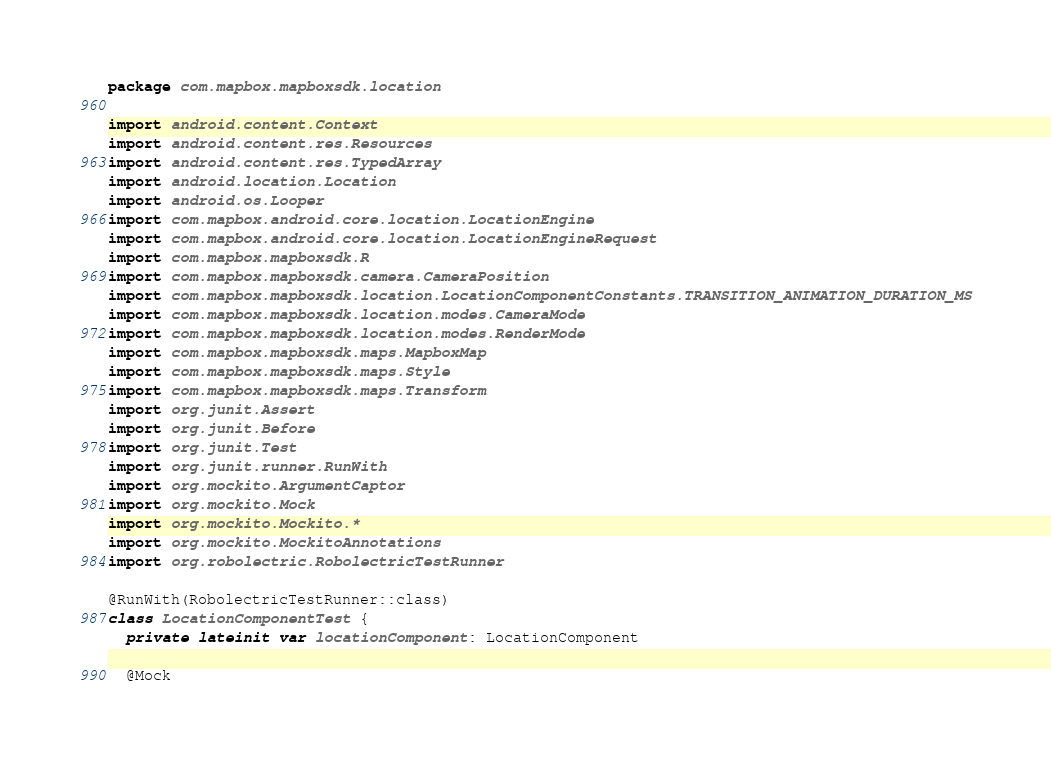<code> <loc_0><loc_0><loc_500><loc_500><_Kotlin_>package com.mapbox.mapboxsdk.location

import android.content.Context
import android.content.res.Resources
import android.content.res.TypedArray
import android.location.Location
import android.os.Looper
import com.mapbox.android.core.location.LocationEngine
import com.mapbox.android.core.location.LocationEngineRequest
import com.mapbox.mapboxsdk.R
import com.mapbox.mapboxsdk.camera.CameraPosition
import com.mapbox.mapboxsdk.location.LocationComponentConstants.TRANSITION_ANIMATION_DURATION_MS
import com.mapbox.mapboxsdk.location.modes.CameraMode
import com.mapbox.mapboxsdk.location.modes.RenderMode
import com.mapbox.mapboxsdk.maps.MapboxMap
import com.mapbox.mapboxsdk.maps.Style
import com.mapbox.mapboxsdk.maps.Transform
import org.junit.Assert
import org.junit.Before
import org.junit.Test
import org.junit.runner.RunWith
import org.mockito.ArgumentCaptor
import org.mockito.Mock
import org.mockito.Mockito.*
import org.mockito.MockitoAnnotations
import org.robolectric.RobolectricTestRunner

@RunWith(RobolectricTestRunner::class)
class LocationComponentTest {
  private lateinit var locationComponent: LocationComponent

  @Mock</code> 